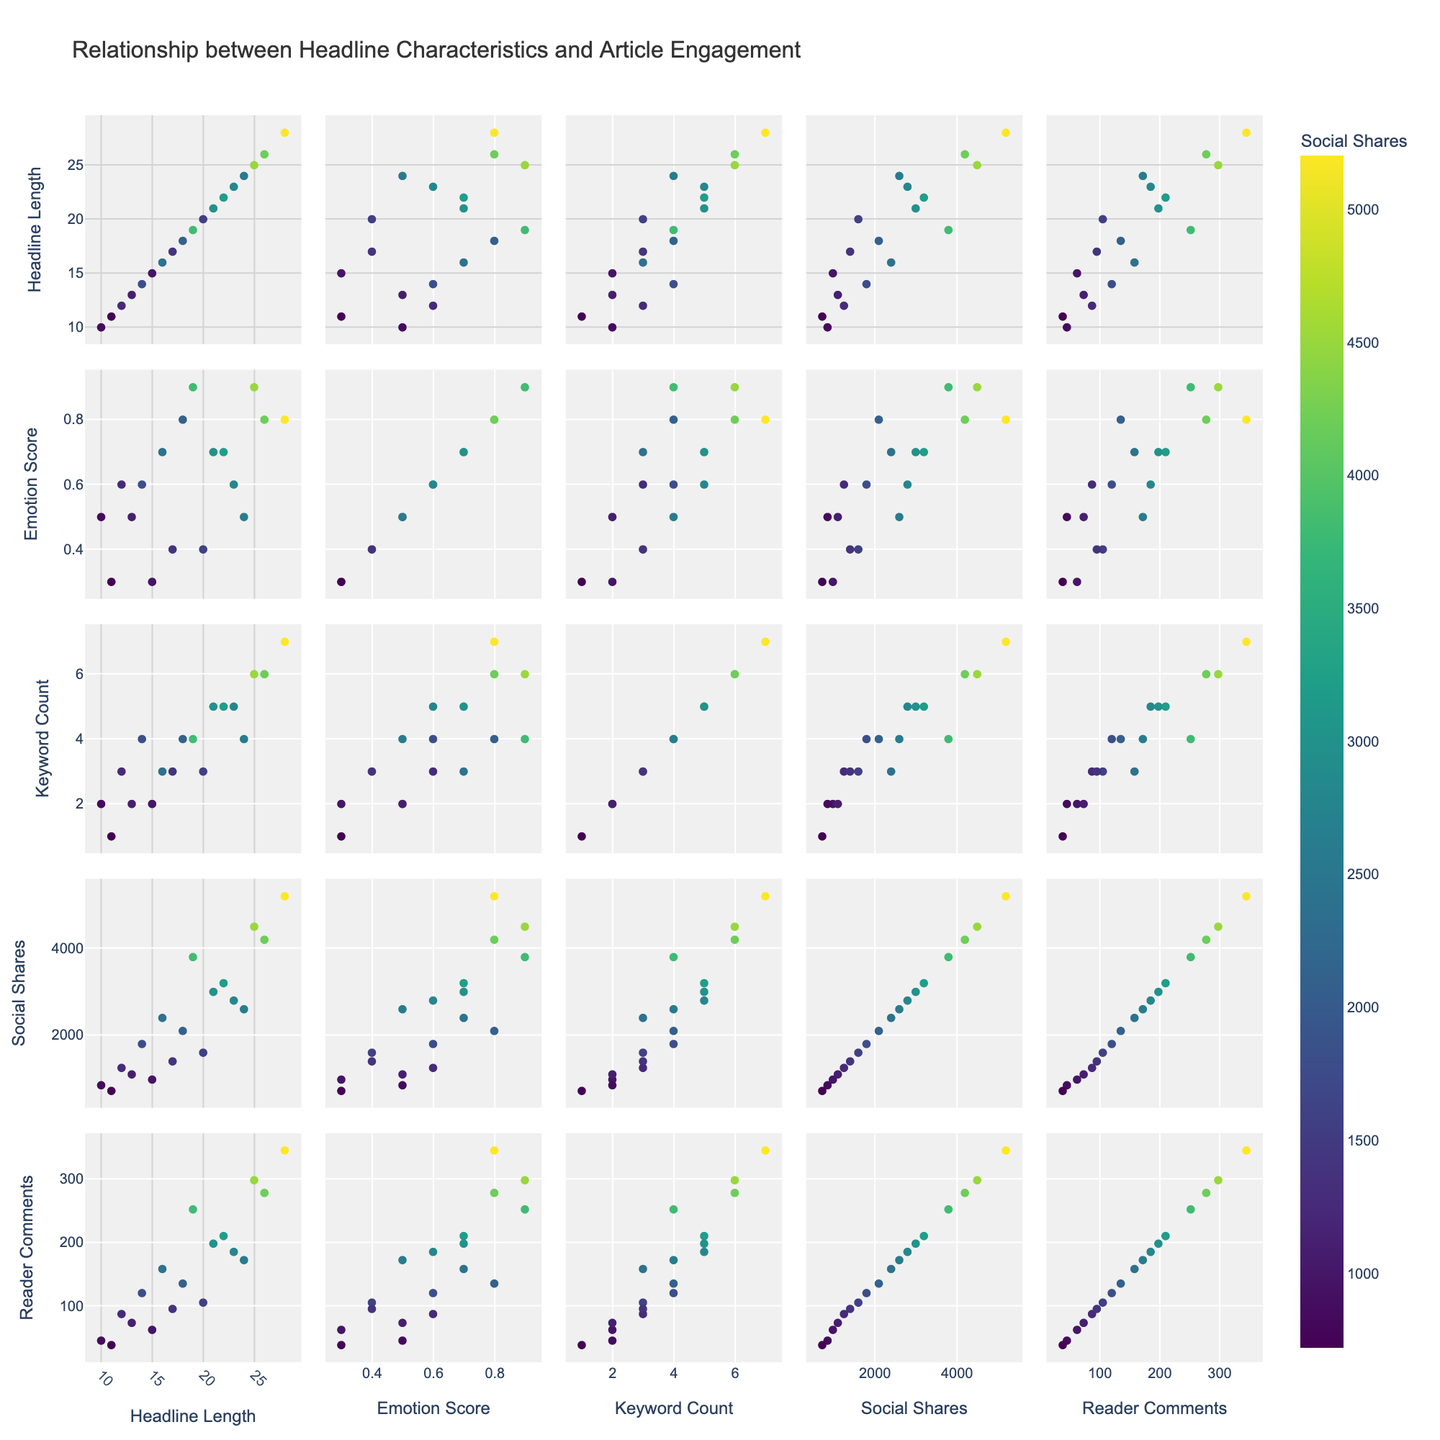What is the title of the scatterplot matrix? The title can be found at the top of the figure. It describes the overall purpose or the main topic of the visualization.
Answer: Relationship between Headline Characteristics and Article Engagement How many dimensions are used in the scatterplot matrix? The scatterplot matrix is formed by creating pairwise plots between the different variables. There are five variables visible in the dimensions list: ‘Headline Length,’ ‘Emotion Score,’ ‘Keyword Count,’ ‘Social Shares,’ and ‘Reader Comments.’
Answer: 5 Which variable is indicated by the color in the scatterplots? The legend or color scale on the scatterplot matrix shows that color intensity represents the 'Social Shares' variable.
Answer: Social Shares What can you infer about the relationship between 'Emotion Score' and 'Reader Comments'? By examining the off-diagonal scatterplots between 'Emotion Score' and 'Reader Comments,' one can observe whether there is a trend, such as an increase or decrease, indicating a possible relationship.
Answer: As 'Emotion Score' increases, 'Reader Comments' tend to increase, showing a positive relationship Between 'Headline Length' and 'Social Shares,' which combination results in higher social shares? Look at the scatterplot between 'Headline Length' and 'Social Shares' and identify the points with darker colors, as the color intensity indicates higher social shares.
Answer: Longer headlines generally result in higher social shares What is the highest number of 'Reader Comments' associated with any data point in the matrix? Find the scatterplot where 'Reader Comments' are used as one axis and identify the maximum value pointed in the plot.
Answer: 345 What is the general trend observed between ‘Keyword Count’ and ‘Social Shares’? By examining the scatterplot between 'Keyword Count' and 'Social Shares,' observe whether an increase in keyword count corresponds to an increase in social shares.
Answer: More keywords generally correlate with higher social shares Which variable pair demonstrates a non-linear relationship in the scatterplot matrix? Review all cross-plots for any bend or curvature rather than a linear straight-line pattern.
Answer: 'Emotion Score' vs. 'Social Shares' demonstrates non-linear behavior If an article has a headline length of 26, what range could you expect for 'Social Shares'? Locate the points in the scatterplot with 'Headline Length' of 26 and observe the range of associated 'Social Shares.'
Answer: Between 4000 and 4500 Social Shares What could be the possible maximum value for 'Social Shares' based on the scatterplot matrix? Identify the scatterplot involving 'Social Shares' and find the maximum data point marking higher social share values.
Answer: 5200 